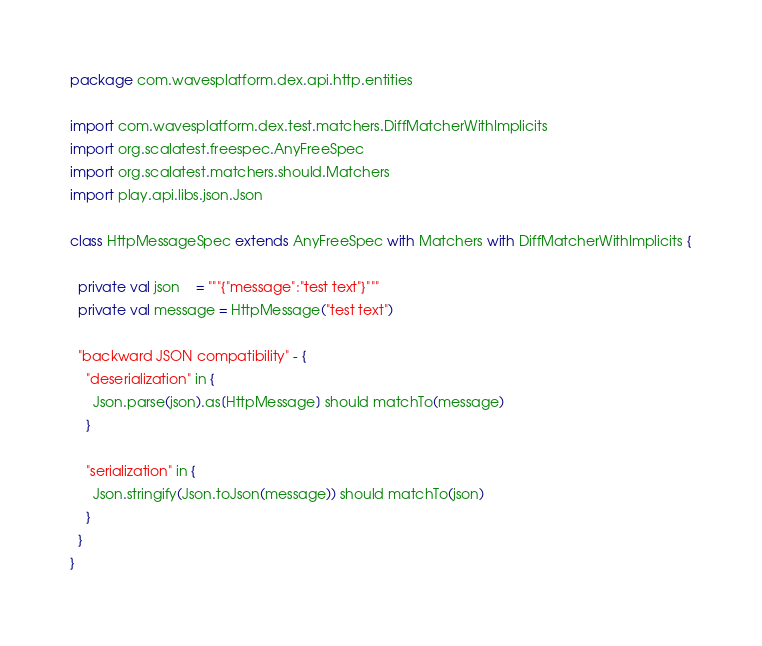Convert code to text. <code><loc_0><loc_0><loc_500><loc_500><_Scala_>package com.wavesplatform.dex.api.http.entities

import com.wavesplatform.dex.test.matchers.DiffMatcherWithImplicits
import org.scalatest.freespec.AnyFreeSpec
import org.scalatest.matchers.should.Matchers
import play.api.libs.json.Json

class HttpMessageSpec extends AnyFreeSpec with Matchers with DiffMatcherWithImplicits {

  private val json    = """{"message":"test text"}"""
  private val message = HttpMessage("test text")

  "backward JSON compatibility" - {
    "deserialization" in {
      Json.parse(json).as[HttpMessage] should matchTo(message)
    }

    "serialization" in {
      Json.stringify(Json.toJson(message)) should matchTo(json)
    }
  }
}
</code> 